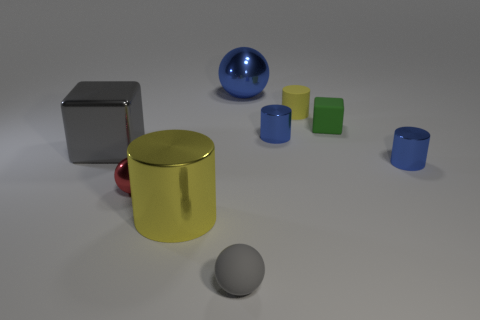Subtract 1 cylinders. How many cylinders are left? 3 Add 1 small blue metal objects. How many objects exist? 10 Subtract all balls. How many objects are left? 6 Subtract 0 cyan cubes. How many objects are left? 9 Subtract all tiny balls. Subtract all small balls. How many objects are left? 5 Add 1 large gray metallic cubes. How many large gray metallic cubes are left? 2 Add 5 tiny green matte objects. How many tiny green matte objects exist? 6 